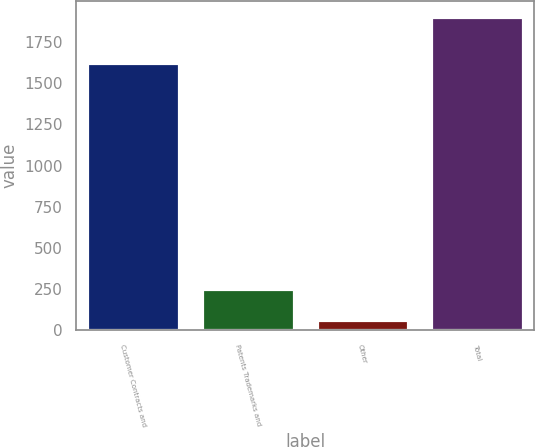Convert chart. <chart><loc_0><loc_0><loc_500><loc_500><bar_chart><fcel>Customer Contracts and<fcel>Patents Trademarks and<fcel>Other<fcel>Total<nl><fcel>1625<fcel>248.9<fcel>65<fcel>1904<nl></chart> 